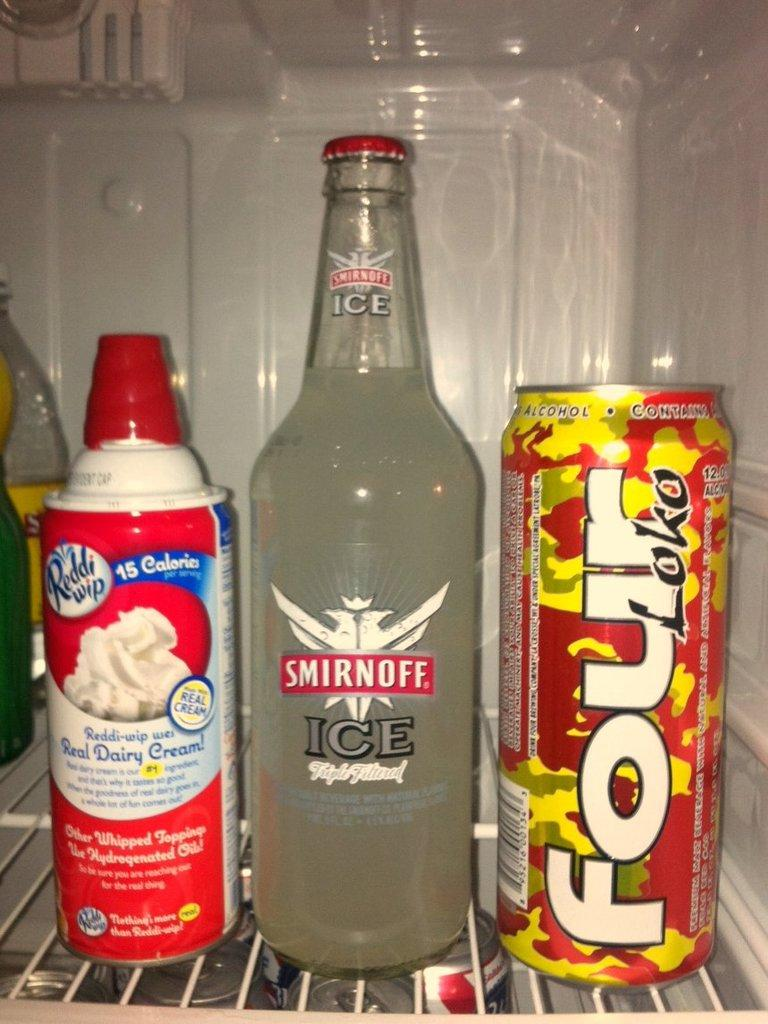Provide a one-sentence caption for the provided image. Bottle of Smirnoff Ice sits on the fridge shelf between Rddi wip and Four Loko. 